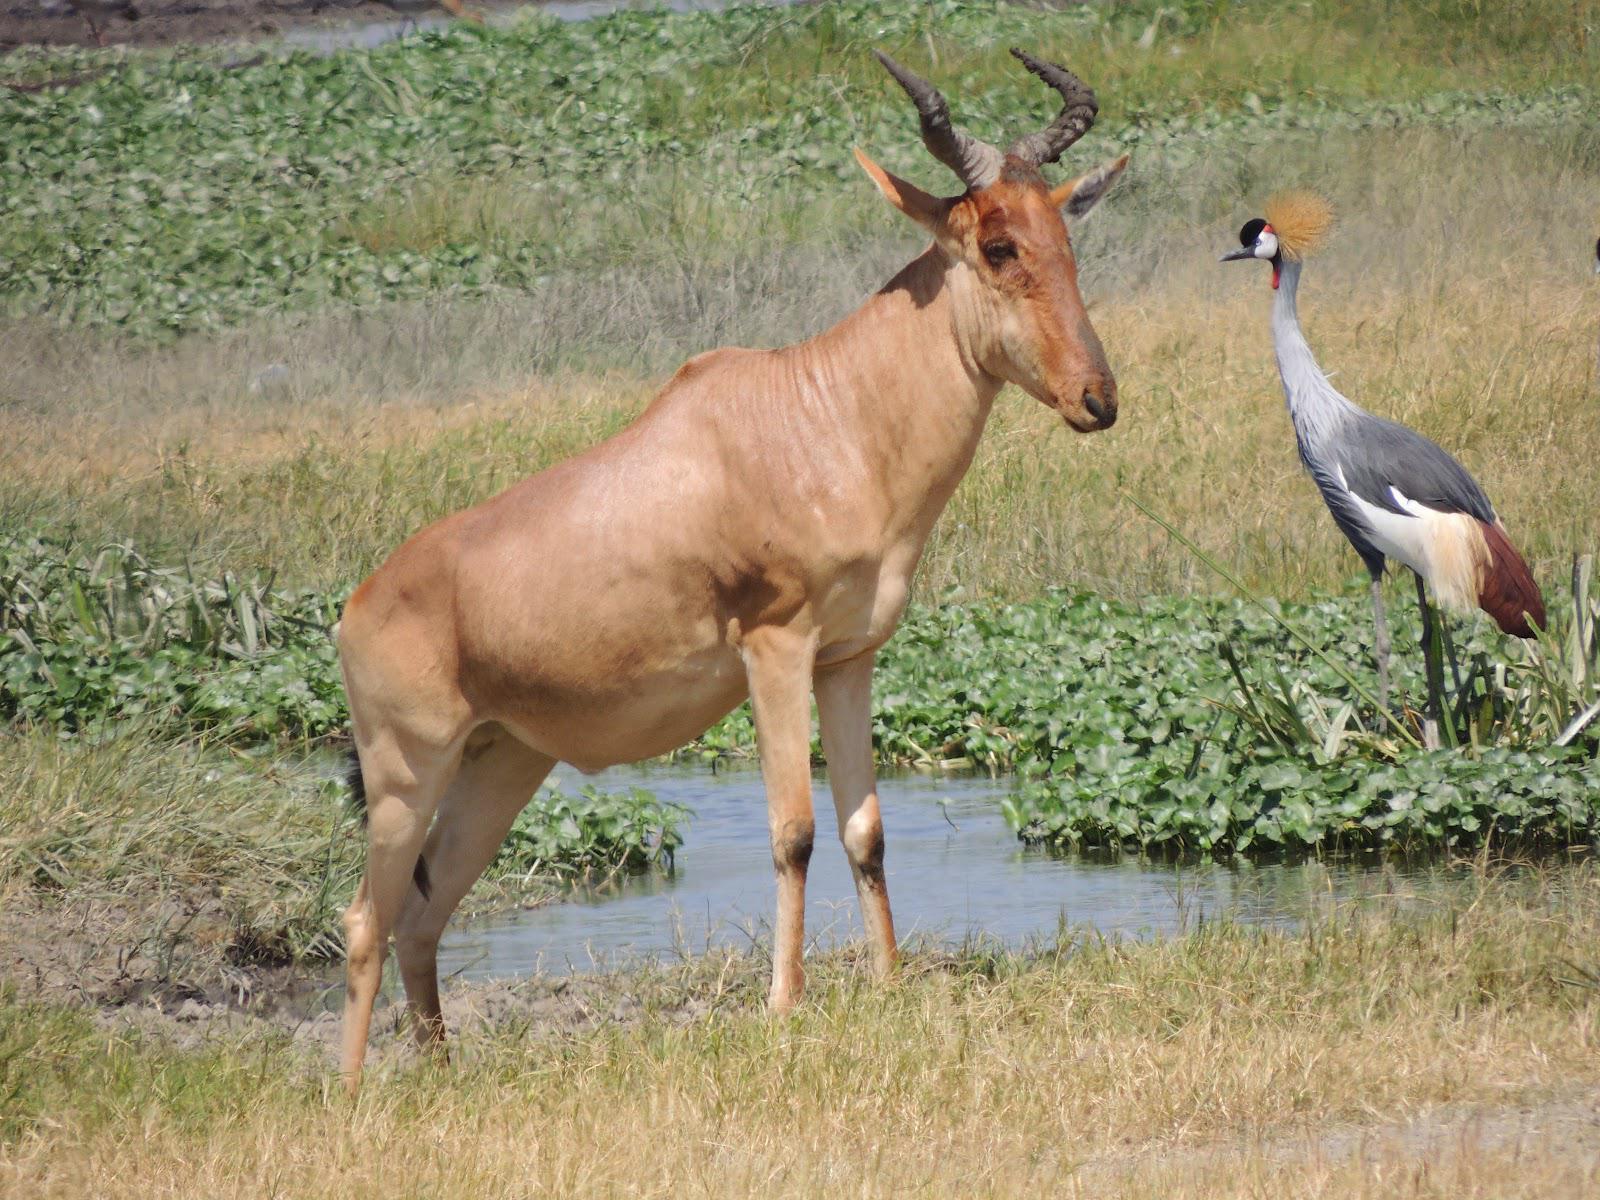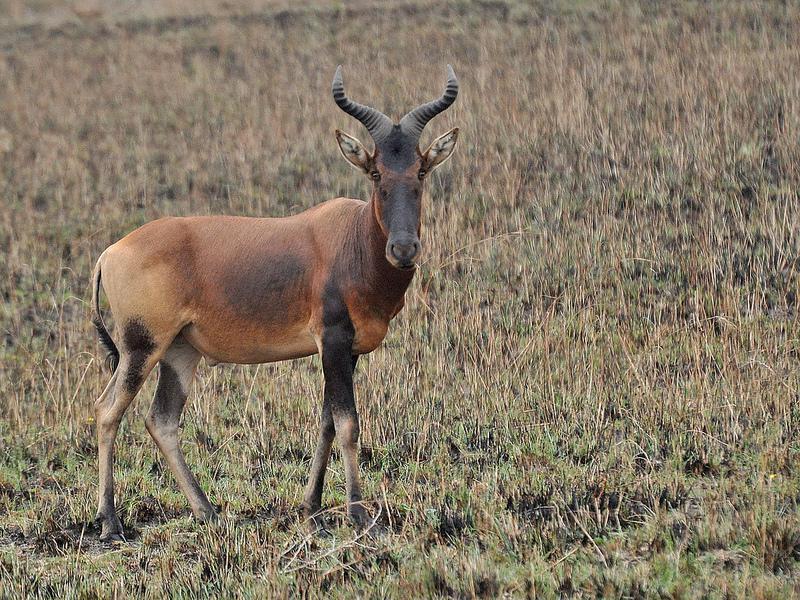The first image is the image on the left, the second image is the image on the right. For the images shown, is this caption "The left and right image contains the same number of elk walking right." true? Answer yes or no. Yes. 